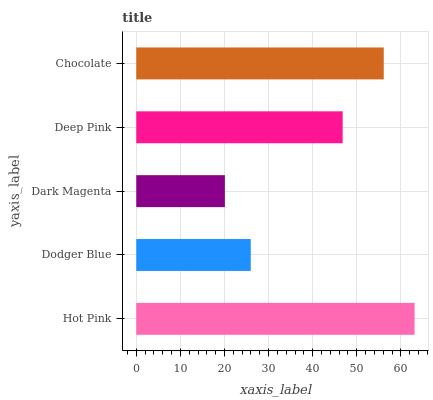Is Dark Magenta the minimum?
Answer yes or no. Yes. Is Hot Pink the maximum?
Answer yes or no. Yes. Is Dodger Blue the minimum?
Answer yes or no. No. Is Dodger Blue the maximum?
Answer yes or no. No. Is Hot Pink greater than Dodger Blue?
Answer yes or no. Yes. Is Dodger Blue less than Hot Pink?
Answer yes or no. Yes. Is Dodger Blue greater than Hot Pink?
Answer yes or no. No. Is Hot Pink less than Dodger Blue?
Answer yes or no. No. Is Deep Pink the high median?
Answer yes or no. Yes. Is Deep Pink the low median?
Answer yes or no. Yes. Is Dark Magenta the high median?
Answer yes or no. No. Is Dark Magenta the low median?
Answer yes or no. No. 